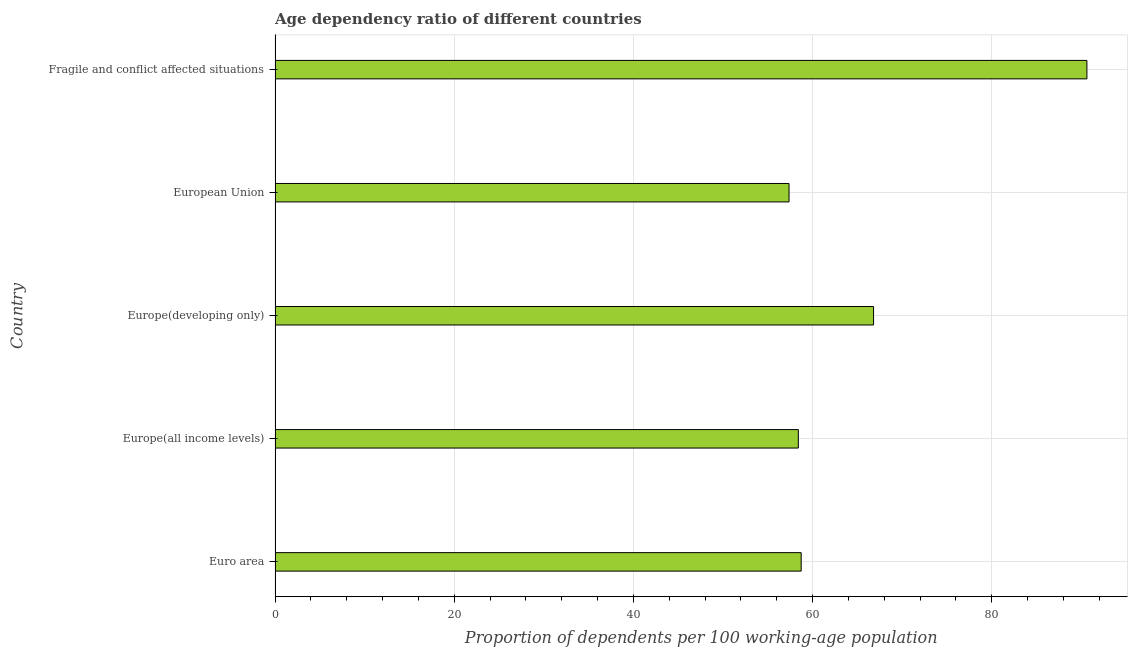What is the title of the graph?
Offer a very short reply. Age dependency ratio of different countries. What is the label or title of the X-axis?
Provide a succinct answer. Proportion of dependents per 100 working-age population. What is the label or title of the Y-axis?
Give a very brief answer. Country. What is the age dependency ratio in Europe(all income levels)?
Provide a succinct answer. 58.41. Across all countries, what is the maximum age dependency ratio?
Your answer should be compact. 90.62. Across all countries, what is the minimum age dependency ratio?
Provide a succinct answer. 57.37. In which country was the age dependency ratio maximum?
Give a very brief answer. Fragile and conflict affected situations. What is the sum of the age dependency ratio?
Ensure brevity in your answer.  331.93. What is the difference between the age dependency ratio in Euro area and Fragile and conflict affected situations?
Offer a terse response. -31.89. What is the average age dependency ratio per country?
Offer a terse response. 66.39. What is the median age dependency ratio?
Your response must be concise. 58.73. What is the ratio of the age dependency ratio in Euro area to that in Fragile and conflict affected situations?
Your answer should be very brief. 0.65. Is the age dependency ratio in Euro area less than that in Fragile and conflict affected situations?
Provide a short and direct response. Yes. What is the difference between the highest and the second highest age dependency ratio?
Ensure brevity in your answer.  23.82. What is the difference between the highest and the lowest age dependency ratio?
Your response must be concise. 33.25. In how many countries, is the age dependency ratio greater than the average age dependency ratio taken over all countries?
Your answer should be compact. 2. How many bars are there?
Offer a very short reply. 5. How many countries are there in the graph?
Make the answer very short. 5. What is the difference between two consecutive major ticks on the X-axis?
Give a very brief answer. 20. Are the values on the major ticks of X-axis written in scientific E-notation?
Keep it short and to the point. No. What is the Proportion of dependents per 100 working-age population in Euro area?
Offer a very short reply. 58.73. What is the Proportion of dependents per 100 working-age population in Europe(all income levels)?
Provide a short and direct response. 58.41. What is the Proportion of dependents per 100 working-age population in Europe(developing only)?
Offer a terse response. 66.81. What is the Proportion of dependents per 100 working-age population of European Union?
Make the answer very short. 57.37. What is the Proportion of dependents per 100 working-age population in Fragile and conflict affected situations?
Your answer should be compact. 90.62. What is the difference between the Proportion of dependents per 100 working-age population in Euro area and Europe(all income levels)?
Offer a very short reply. 0.32. What is the difference between the Proportion of dependents per 100 working-age population in Euro area and Europe(developing only)?
Offer a terse response. -8.08. What is the difference between the Proportion of dependents per 100 working-age population in Euro area and European Union?
Your answer should be compact. 1.36. What is the difference between the Proportion of dependents per 100 working-age population in Euro area and Fragile and conflict affected situations?
Your response must be concise. -31.89. What is the difference between the Proportion of dependents per 100 working-age population in Europe(all income levels) and Europe(developing only)?
Ensure brevity in your answer.  -8.4. What is the difference between the Proportion of dependents per 100 working-age population in Europe(all income levels) and European Union?
Ensure brevity in your answer.  1.04. What is the difference between the Proportion of dependents per 100 working-age population in Europe(all income levels) and Fragile and conflict affected situations?
Give a very brief answer. -32.21. What is the difference between the Proportion of dependents per 100 working-age population in Europe(developing only) and European Union?
Your answer should be very brief. 9.43. What is the difference between the Proportion of dependents per 100 working-age population in Europe(developing only) and Fragile and conflict affected situations?
Your response must be concise. -23.82. What is the difference between the Proportion of dependents per 100 working-age population in European Union and Fragile and conflict affected situations?
Your answer should be compact. -33.25. What is the ratio of the Proportion of dependents per 100 working-age population in Euro area to that in Europe(all income levels)?
Offer a very short reply. 1. What is the ratio of the Proportion of dependents per 100 working-age population in Euro area to that in Europe(developing only)?
Give a very brief answer. 0.88. What is the ratio of the Proportion of dependents per 100 working-age population in Euro area to that in European Union?
Provide a succinct answer. 1.02. What is the ratio of the Proportion of dependents per 100 working-age population in Euro area to that in Fragile and conflict affected situations?
Offer a very short reply. 0.65. What is the ratio of the Proportion of dependents per 100 working-age population in Europe(all income levels) to that in Europe(developing only)?
Make the answer very short. 0.87. What is the ratio of the Proportion of dependents per 100 working-age population in Europe(all income levels) to that in European Union?
Provide a succinct answer. 1.02. What is the ratio of the Proportion of dependents per 100 working-age population in Europe(all income levels) to that in Fragile and conflict affected situations?
Your response must be concise. 0.65. What is the ratio of the Proportion of dependents per 100 working-age population in Europe(developing only) to that in European Union?
Provide a short and direct response. 1.16. What is the ratio of the Proportion of dependents per 100 working-age population in Europe(developing only) to that in Fragile and conflict affected situations?
Provide a short and direct response. 0.74. What is the ratio of the Proportion of dependents per 100 working-age population in European Union to that in Fragile and conflict affected situations?
Offer a terse response. 0.63. 